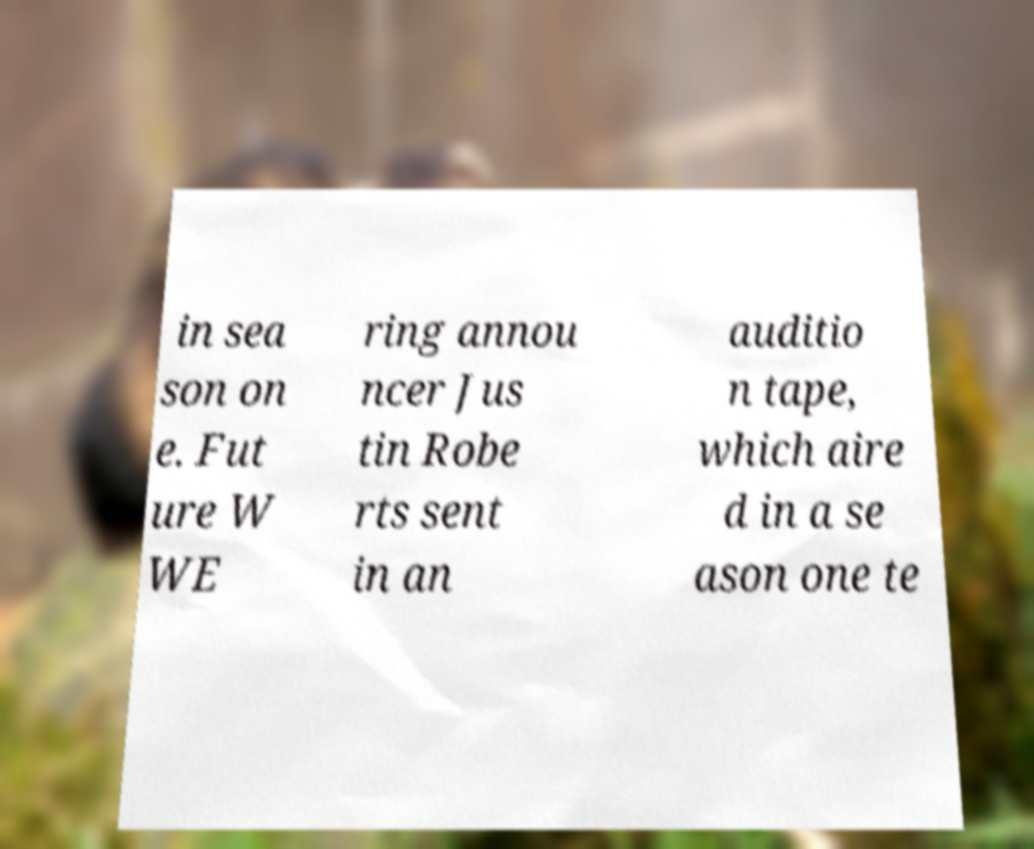Can you accurately transcribe the text from the provided image for me? in sea son on e. Fut ure W WE ring annou ncer Jus tin Robe rts sent in an auditio n tape, which aire d in a se ason one te 